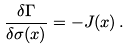Convert formula to latex. <formula><loc_0><loc_0><loc_500><loc_500>\frac { \delta \Gamma } { \delta \sigma ( x ) } = - J ( x ) \, .</formula> 